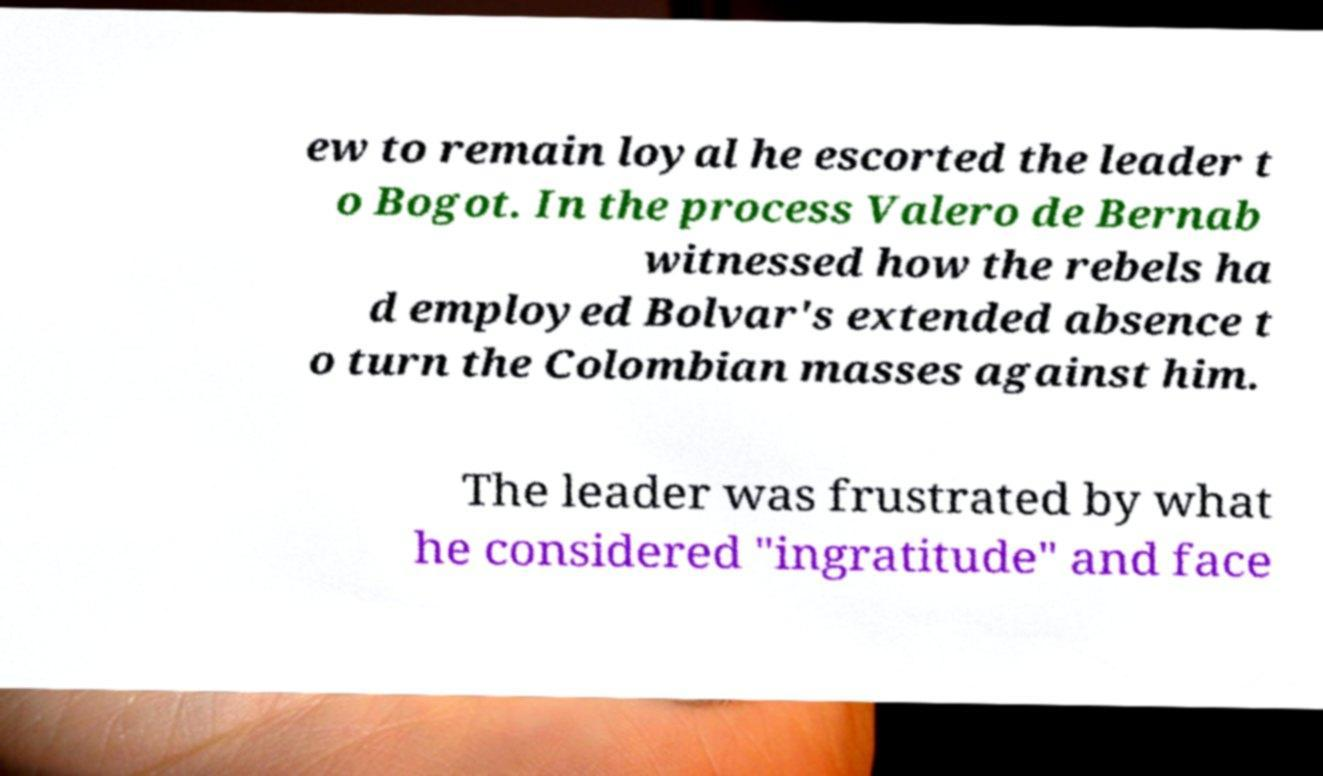Can you accurately transcribe the text from the provided image for me? ew to remain loyal he escorted the leader t o Bogot. In the process Valero de Bernab witnessed how the rebels ha d employed Bolvar's extended absence t o turn the Colombian masses against him. The leader was frustrated by what he considered "ingratitude" and face 